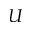Convert formula to latex. <formula><loc_0><loc_0><loc_500><loc_500>U</formula> 